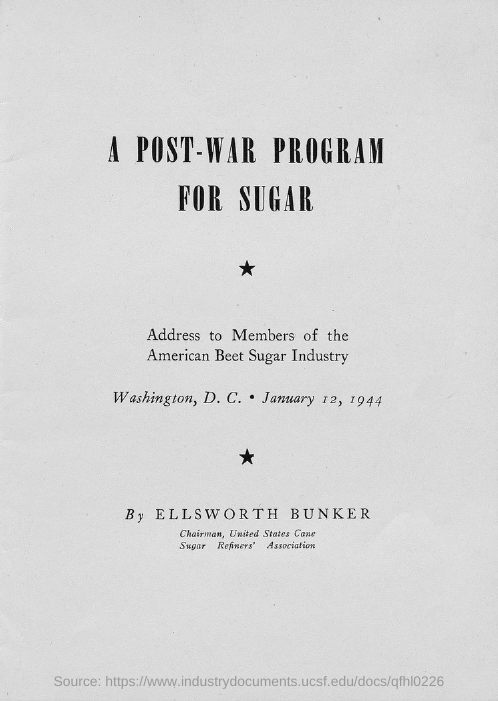What is the title of the document?
Your answer should be compact. A POST-WAR PROGRAM FOR SUGAR. 